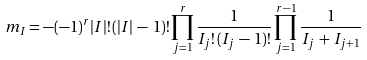Convert formula to latex. <formula><loc_0><loc_0><loc_500><loc_500>m _ { I } = - ( - 1 ) ^ { r } | I | ! \, ( | I | \, - \, 1 ) ! \prod _ { j = 1 } ^ { r } \frac { 1 } { I _ { j } ! \, ( I _ { j } \, - \, 1 ) ! } \prod _ { j = 1 } ^ { r - 1 } \frac { 1 } { I _ { j } \, + \, I _ { j + 1 } }</formula> 